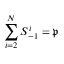Convert formula to latex. <formula><loc_0><loc_0><loc_500><loc_500>\sum _ { i = 2 } ^ { N } S _ { - 1 } ^ { i } = \mathfrak { p }</formula> 